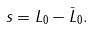<formula> <loc_0><loc_0><loc_500><loc_500>s = L _ { 0 } - \bar { L } _ { 0 } .</formula> 